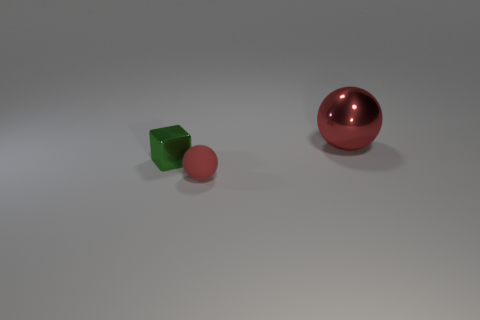Can you describe the colors visible in the image and explain what they may symbolize or represent? The image contains three distinct colors: green, pink, and red. These colors could symbolize various concepts; green is often associated with growth or tranquility, pink might represent gentleness or warmth, while red could connote energy or passion. The exact symbolism can vary based on cultural or contextual factors, but in this abstract setting, they could simply be a way to differentiate the objects. 